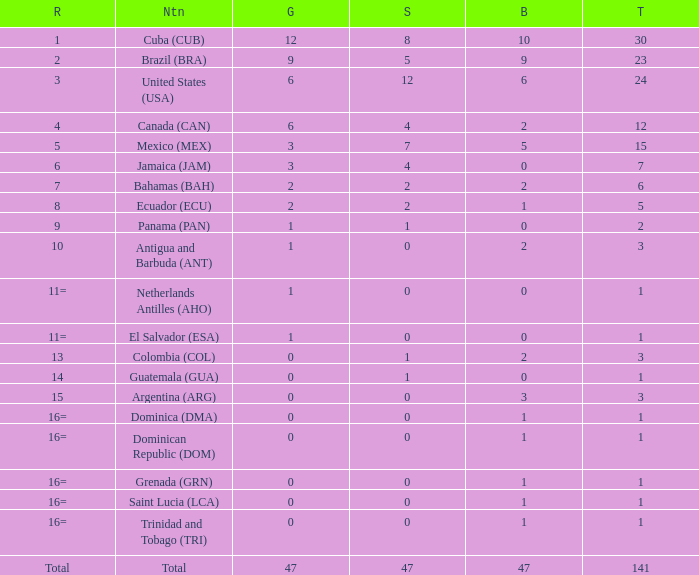How many bronzes have a Nation of jamaica (jam), and a Total smaller than 7? 0.0. Give me the full table as a dictionary. {'header': ['R', 'Ntn', 'G', 'S', 'B', 'T'], 'rows': [['1', 'Cuba (CUB)', '12', '8', '10', '30'], ['2', 'Brazil (BRA)', '9', '5', '9', '23'], ['3', 'United States (USA)', '6', '12', '6', '24'], ['4', 'Canada (CAN)', '6', '4', '2', '12'], ['5', 'Mexico (MEX)', '3', '7', '5', '15'], ['6', 'Jamaica (JAM)', '3', '4', '0', '7'], ['7', 'Bahamas (BAH)', '2', '2', '2', '6'], ['8', 'Ecuador (ECU)', '2', '2', '1', '5'], ['9', 'Panama (PAN)', '1', '1', '0', '2'], ['10', 'Antigua and Barbuda (ANT)', '1', '0', '2', '3'], ['11=', 'Netherlands Antilles (AHO)', '1', '0', '0', '1'], ['11=', 'El Salvador (ESA)', '1', '0', '0', '1'], ['13', 'Colombia (COL)', '0', '1', '2', '3'], ['14', 'Guatemala (GUA)', '0', '1', '0', '1'], ['15', 'Argentina (ARG)', '0', '0', '3', '3'], ['16=', 'Dominica (DMA)', '0', '0', '1', '1'], ['16=', 'Dominican Republic (DOM)', '0', '0', '1', '1'], ['16=', 'Grenada (GRN)', '0', '0', '1', '1'], ['16=', 'Saint Lucia (LCA)', '0', '0', '1', '1'], ['16=', 'Trinidad and Tobago (TRI)', '0', '0', '1', '1'], ['Total', 'Total', '47', '47', '47', '141']]} 